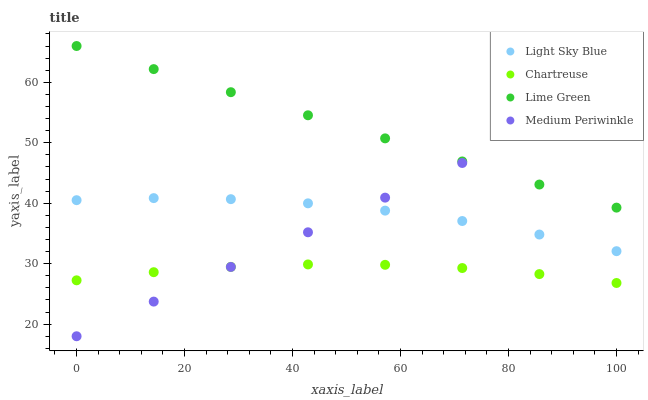Does Chartreuse have the minimum area under the curve?
Answer yes or no. Yes. Does Lime Green have the maximum area under the curve?
Answer yes or no. Yes. Does Light Sky Blue have the minimum area under the curve?
Answer yes or no. No. Does Light Sky Blue have the maximum area under the curve?
Answer yes or no. No. Is Medium Periwinkle the smoothest?
Answer yes or no. Yes. Is Light Sky Blue the roughest?
Answer yes or no. Yes. Is Chartreuse the smoothest?
Answer yes or no. No. Is Chartreuse the roughest?
Answer yes or no. No. Does Medium Periwinkle have the lowest value?
Answer yes or no. Yes. Does Chartreuse have the lowest value?
Answer yes or no. No. Does Lime Green have the highest value?
Answer yes or no. Yes. Does Light Sky Blue have the highest value?
Answer yes or no. No. Is Chartreuse less than Lime Green?
Answer yes or no. Yes. Is Lime Green greater than Light Sky Blue?
Answer yes or no. Yes. Does Light Sky Blue intersect Medium Periwinkle?
Answer yes or no. Yes. Is Light Sky Blue less than Medium Periwinkle?
Answer yes or no. No. Is Light Sky Blue greater than Medium Periwinkle?
Answer yes or no. No. Does Chartreuse intersect Lime Green?
Answer yes or no. No. 